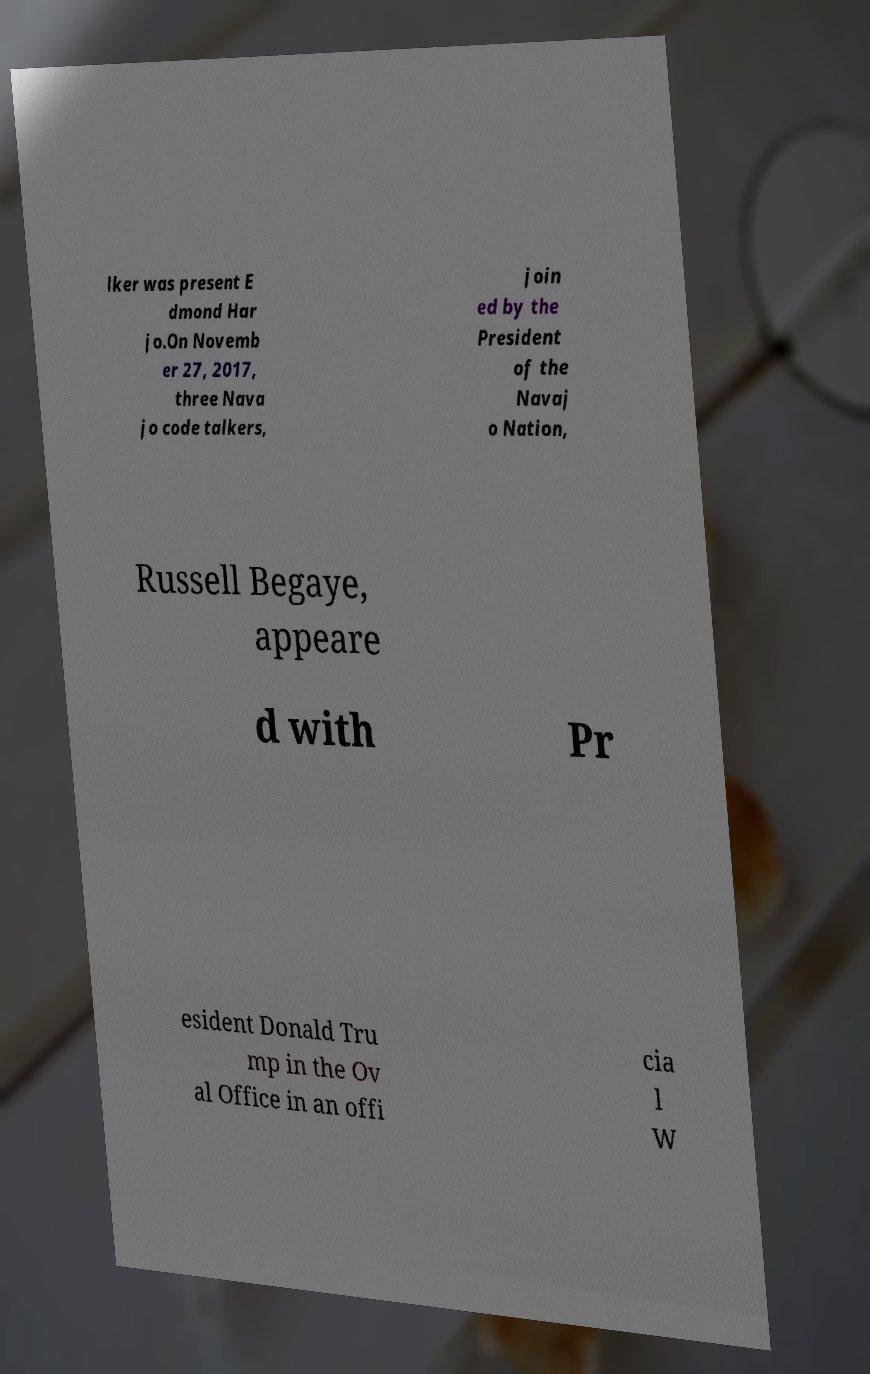Please identify and transcribe the text found in this image. lker was present E dmond Har jo.On Novemb er 27, 2017, three Nava jo code talkers, join ed by the President of the Navaj o Nation, Russell Begaye, appeare d with Pr esident Donald Tru mp in the Ov al Office in an offi cia l W 